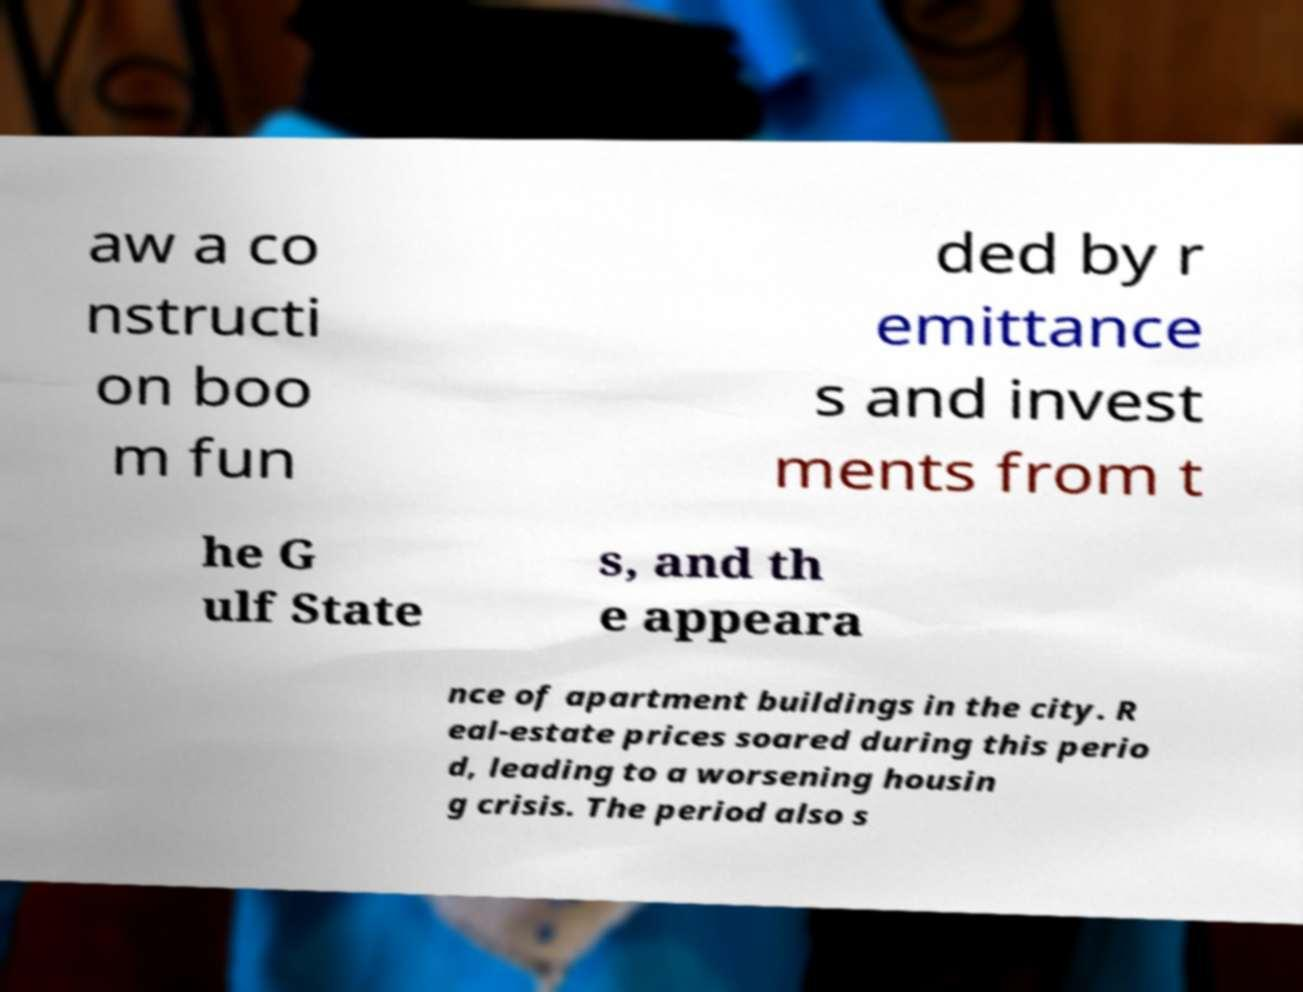Can you accurately transcribe the text from the provided image for me? aw a co nstructi on boo m fun ded by r emittance s and invest ments from t he G ulf State s, and th e appeara nce of apartment buildings in the city. R eal-estate prices soared during this perio d, leading to a worsening housin g crisis. The period also s 